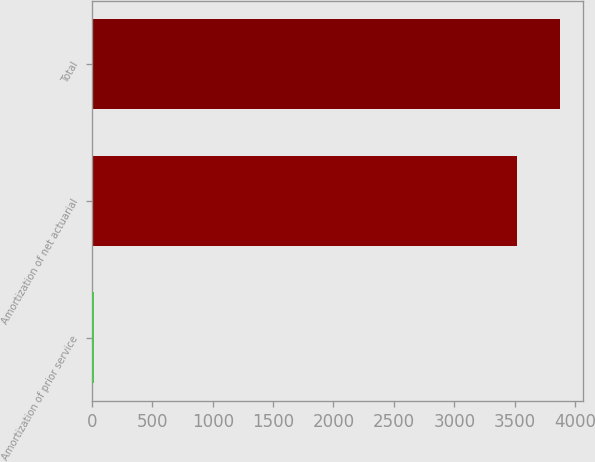Convert chart to OTSL. <chart><loc_0><loc_0><loc_500><loc_500><bar_chart><fcel>Amortization of prior service<fcel>Amortization of net actuarial<fcel>Total<nl><fcel>17<fcel>3523<fcel>3875.3<nl></chart> 